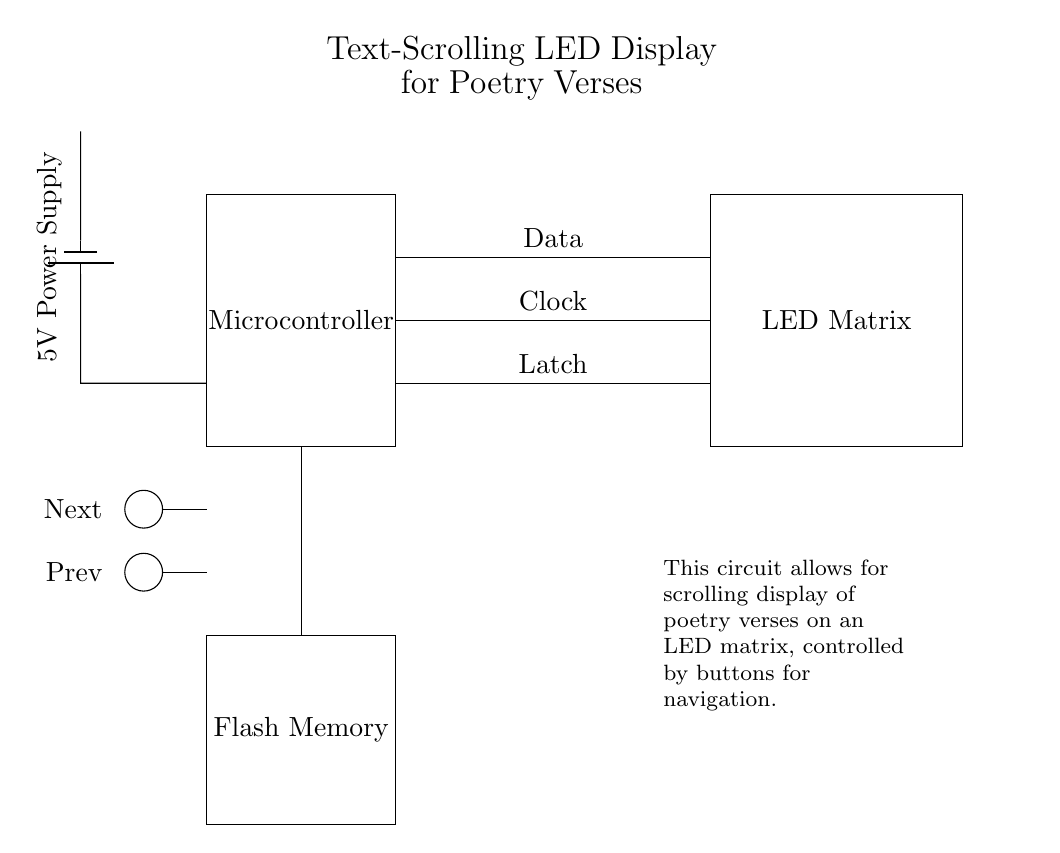What type of display is used in this circuit? The display component is specified as an LED Matrix, which is designed to showcase visual output such as scrolling text.
Answer: LED Matrix What is the purpose of the microcontroller in the circuit? The microcontroller is responsible for controlling the interactivity and logic needed to display the poetry verses on the LED Matrix, processing input from buttons and sending appropriate signals.
Answer: Control How many buttons are present in the circuit? There are two buttons present in the circuit, labeled as Next and Prev, used for navigation through the poetry verses shown on the display.
Answer: Two What is the supply voltage provided to the circuit? The power supply in the circuit is a battery that provides a voltage of 5V, which powers the components like the microcontroller and LED matrix.
Answer: 5V Which component stores the poetry verses? The component designated for storing poetry verses is Flash Memory, as it indicates non-volatile data storage enabling the microcontroller to retrieve and display text.
Answer: Flash Memory What do the connections labeled Data, Clock, and Latch represent? The connections labeled Data, Clock, and Latch are control signals that facilitate the operation of the LED Matrix, allowing the microcontroller to synchronize data transfer and control the display effectively.
Answer: Control signals 